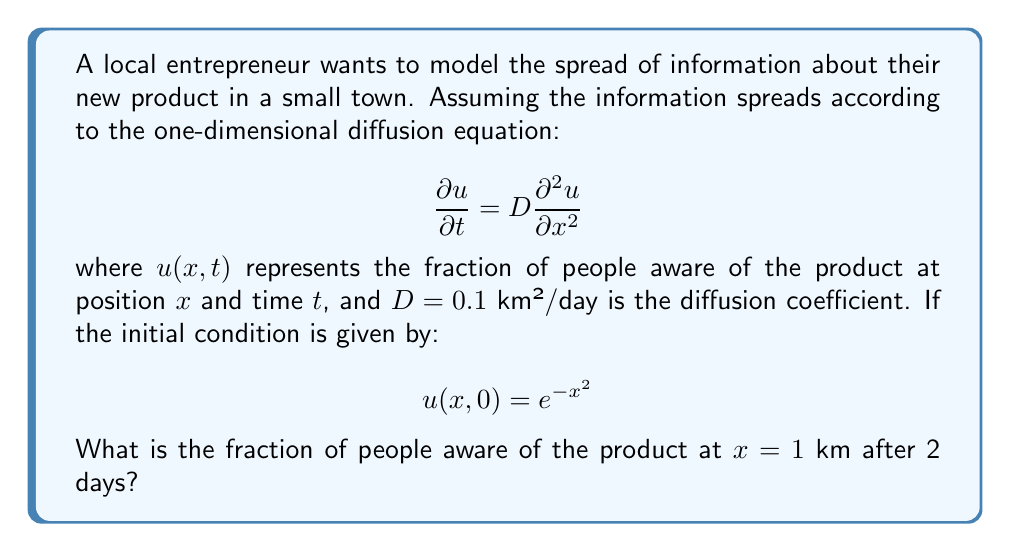Give your solution to this math problem. To solve this problem, we'll use the fundamental solution of the diffusion equation:

1) The general solution for the one-dimensional diffusion equation with the given initial condition is:

   $$ u(x,t) = \frac{1}{\sqrt{1 + 4Dt}} \exp\left(-\frac{x^2}{1 + 4Dt}\right) $$

2) We're given that $D = 0.1$ km²/day, $x = 1$ km, and $t = 2$ days. Let's substitute these values:

   $$ u(1,2) = \frac{1}{\sqrt{1 + 4(0.1)(2)}} \exp\left(-\frac{1^2}{1 + 4(0.1)(2)}\right) $$

3) Simplify the denominator under the square root:
   $$ = \frac{1}{\sqrt{1 + 0.8}} \exp\left(-\frac{1}{1 + 0.8}\right) $$

4) Simplify further:
   $$ = \frac{1}{\sqrt{1.8}} \exp\left(-\frac{1}{1.8}\right) $$

5) Calculate the value:
   $$ \approx 0.7454 \cdot 0.5743 \approx 0.4281 $$

Therefore, after 2 days, approximately 42.81% of people at 1 km from the origin will be aware of the product.
Answer: 0.4281 or 42.81% 